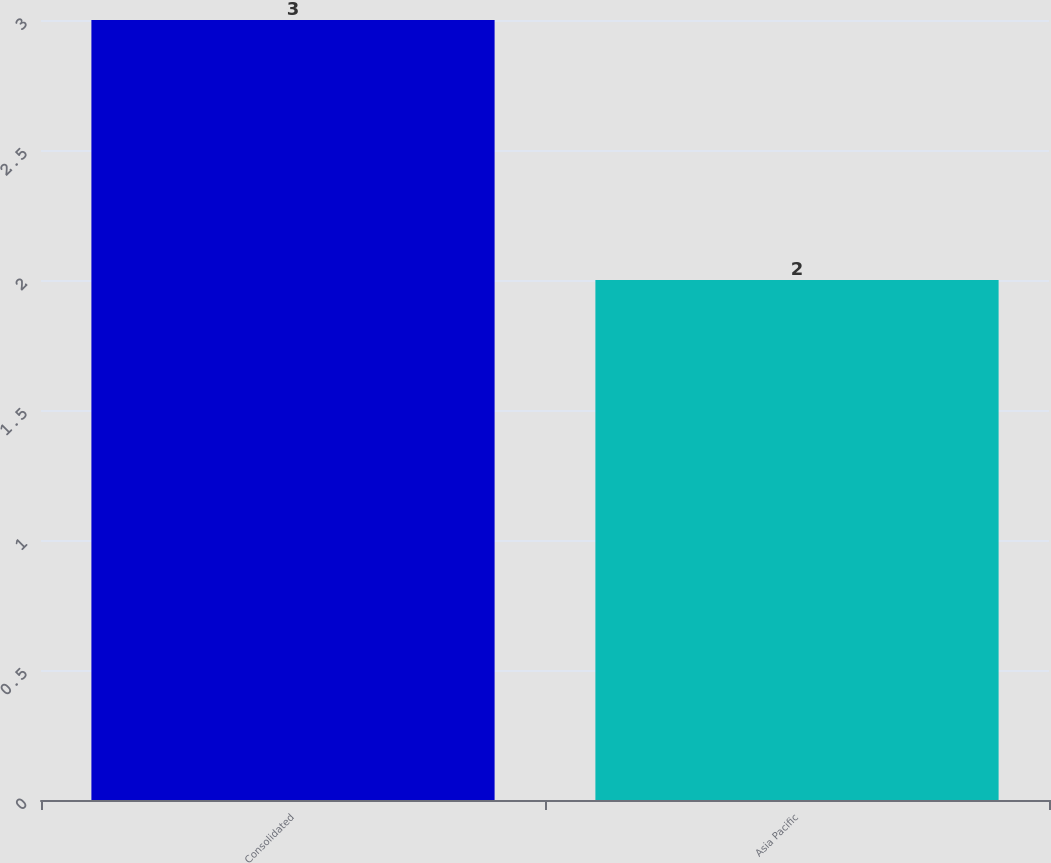Convert chart to OTSL. <chart><loc_0><loc_0><loc_500><loc_500><bar_chart><fcel>Consolidated<fcel>Asia Pacific<nl><fcel>3<fcel>2<nl></chart> 